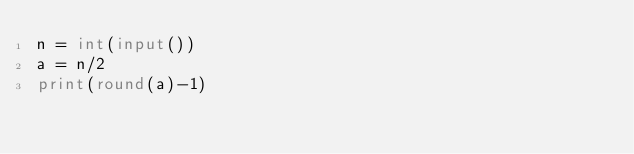Convert code to text. <code><loc_0><loc_0><loc_500><loc_500><_Python_>n = int(input())
a = n/2
print(round(a)-1)</code> 